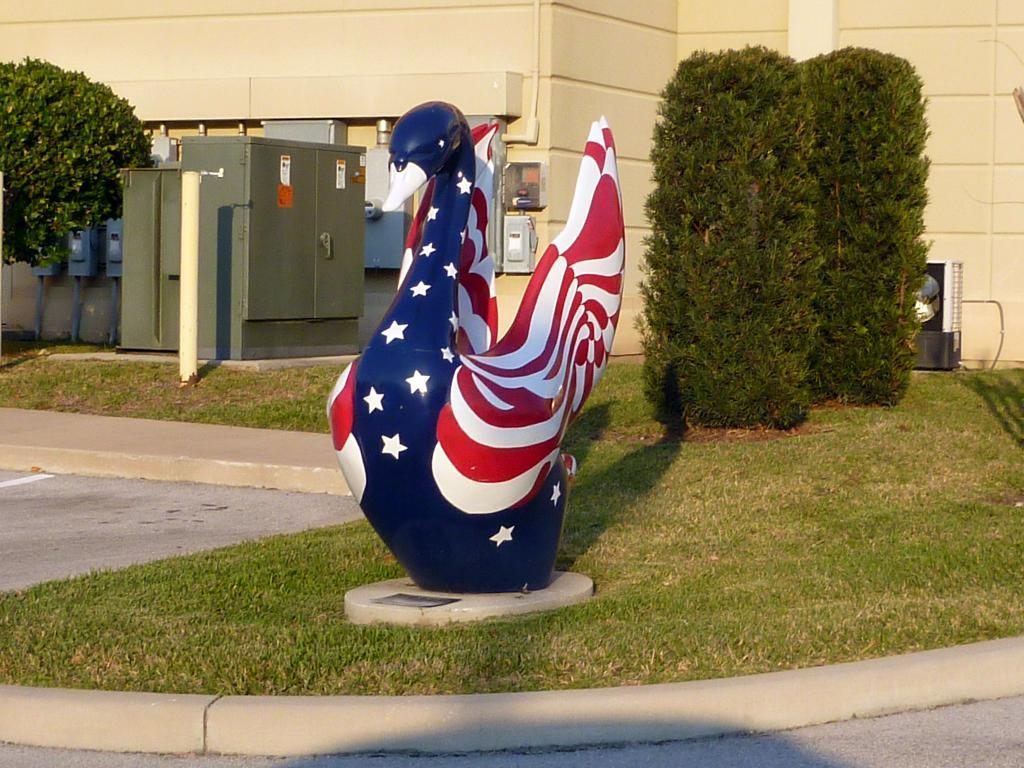What is the main subject in the center of the image? There is a statue of a duck in the center of the image. What can be seen in the background of the image? There is a building, a generator, switch boards, plants, and trees in the background of the image. How much money is being exchanged between the duck and the trees in the image? There is no money exchange depicted in the image; it features a statue of a duck and various background elements. 